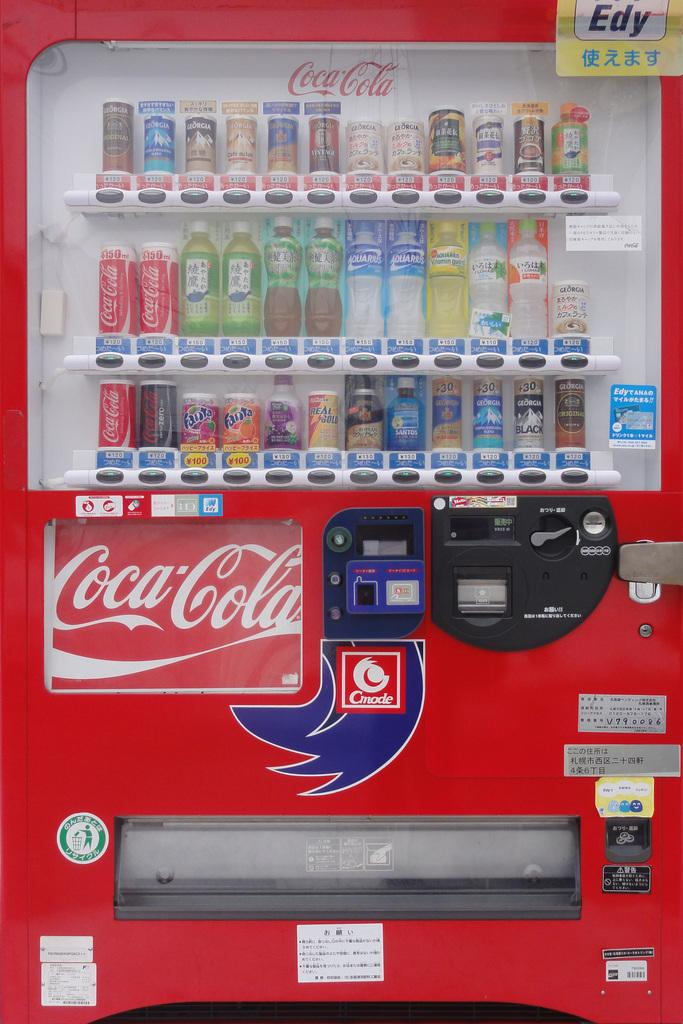<image>
Present a compact description of the photo's key features. a Coca Cola vending machine sells Fanta and Georgia Black drinks 